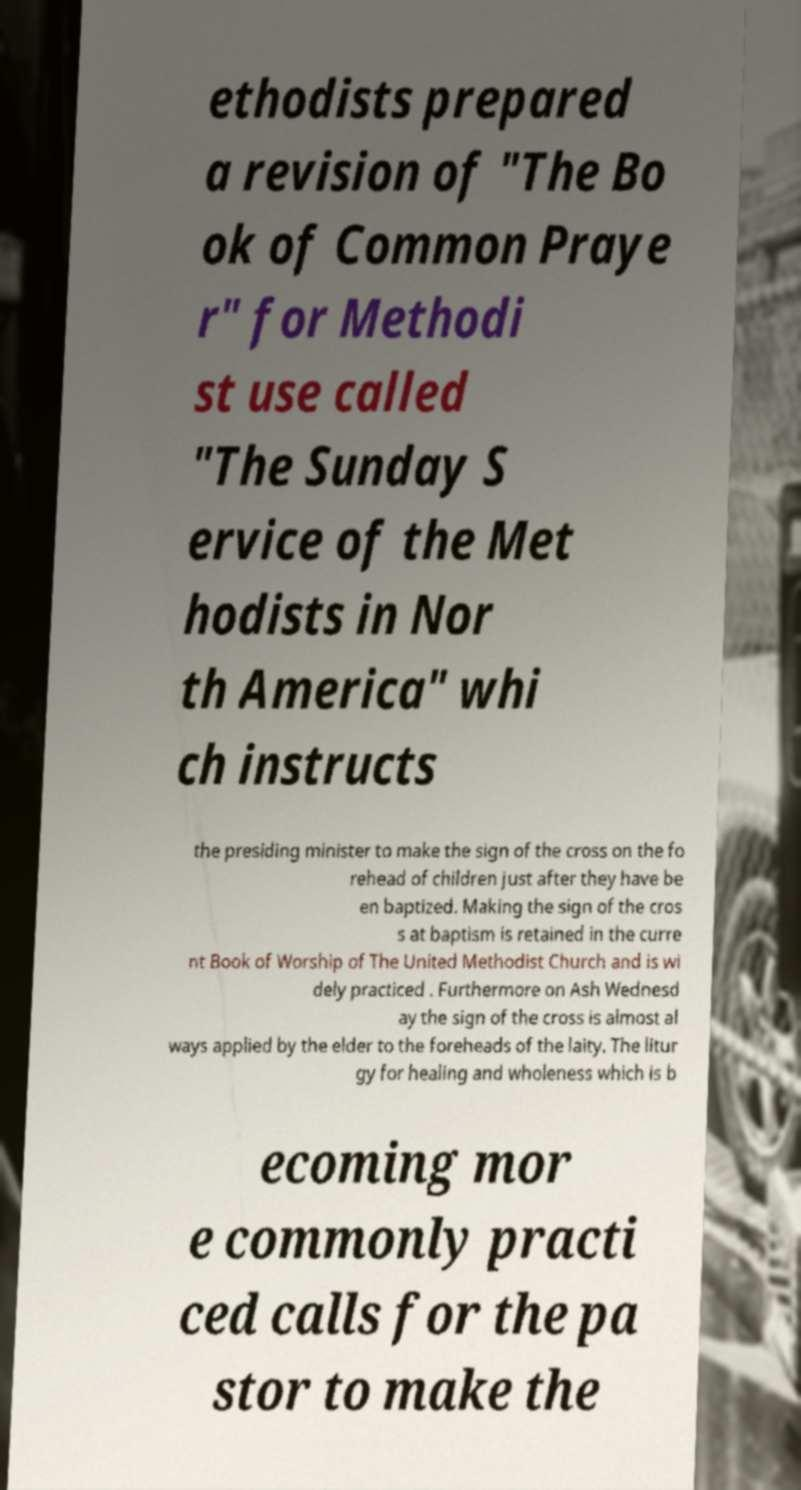Could you extract and type out the text from this image? ethodists prepared a revision of "The Bo ok of Common Praye r" for Methodi st use called "The Sunday S ervice of the Met hodists in Nor th America" whi ch instructs the presiding minister to make the sign of the cross on the fo rehead of children just after they have be en baptized. Making the sign of the cros s at baptism is retained in the curre nt Book of Worship of The United Methodist Church and is wi dely practiced . Furthermore on Ash Wednesd ay the sign of the cross is almost al ways applied by the elder to the foreheads of the laity. The litur gy for healing and wholeness which is b ecoming mor e commonly practi ced calls for the pa stor to make the 